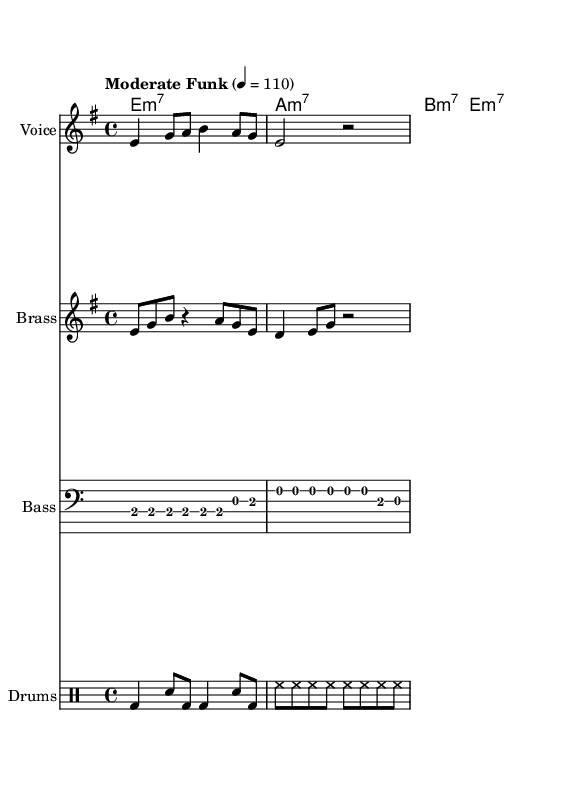What is the key signature of this music? The key signature indicates that there are no sharps or flats, and it is established at the beginning of the score, which points to E minor as the key signature.
Answer: E minor What is the time signature of the music? The time signature is displayed at the beginning of the score, and it reads 4/4, signifying that there are four beats in a measure and that the quarter note receives one beat.
Answer: 4/4 What is the tempo marking indicated in the score? The tempo marking is given at the beginning of the score, stating "Moderate Funk" with a metronome mark of quarter note equals 110, which defines the speed of the piece.
Answer: Moderate Funk 4 = 110 How many measures are in the vocal melody? By counting the measures in the vocal melody line, we can see that there are three measures of music present in the vocal section.
Answer: 3 What instrument plays the brass riff? The instrument is specified in the staff's naming context as "Brass," indicating that the musical line is meant to be played by brass instruments.
Answer: Brass In which section do the lyrics appear? The lyrics are found right below the vocal melody line in the score, where they are aligned with the melody notes.
Answer: Below vocal melody What is the rhythmic structure used in the drum pattern? Analyzing the drum staff reveals a specific pattern, which consists of alternating bass drum and snare drum hits along with hi-hat hits, indicative of a typical funky rhythm.
Answer: Alternating bass and snare 